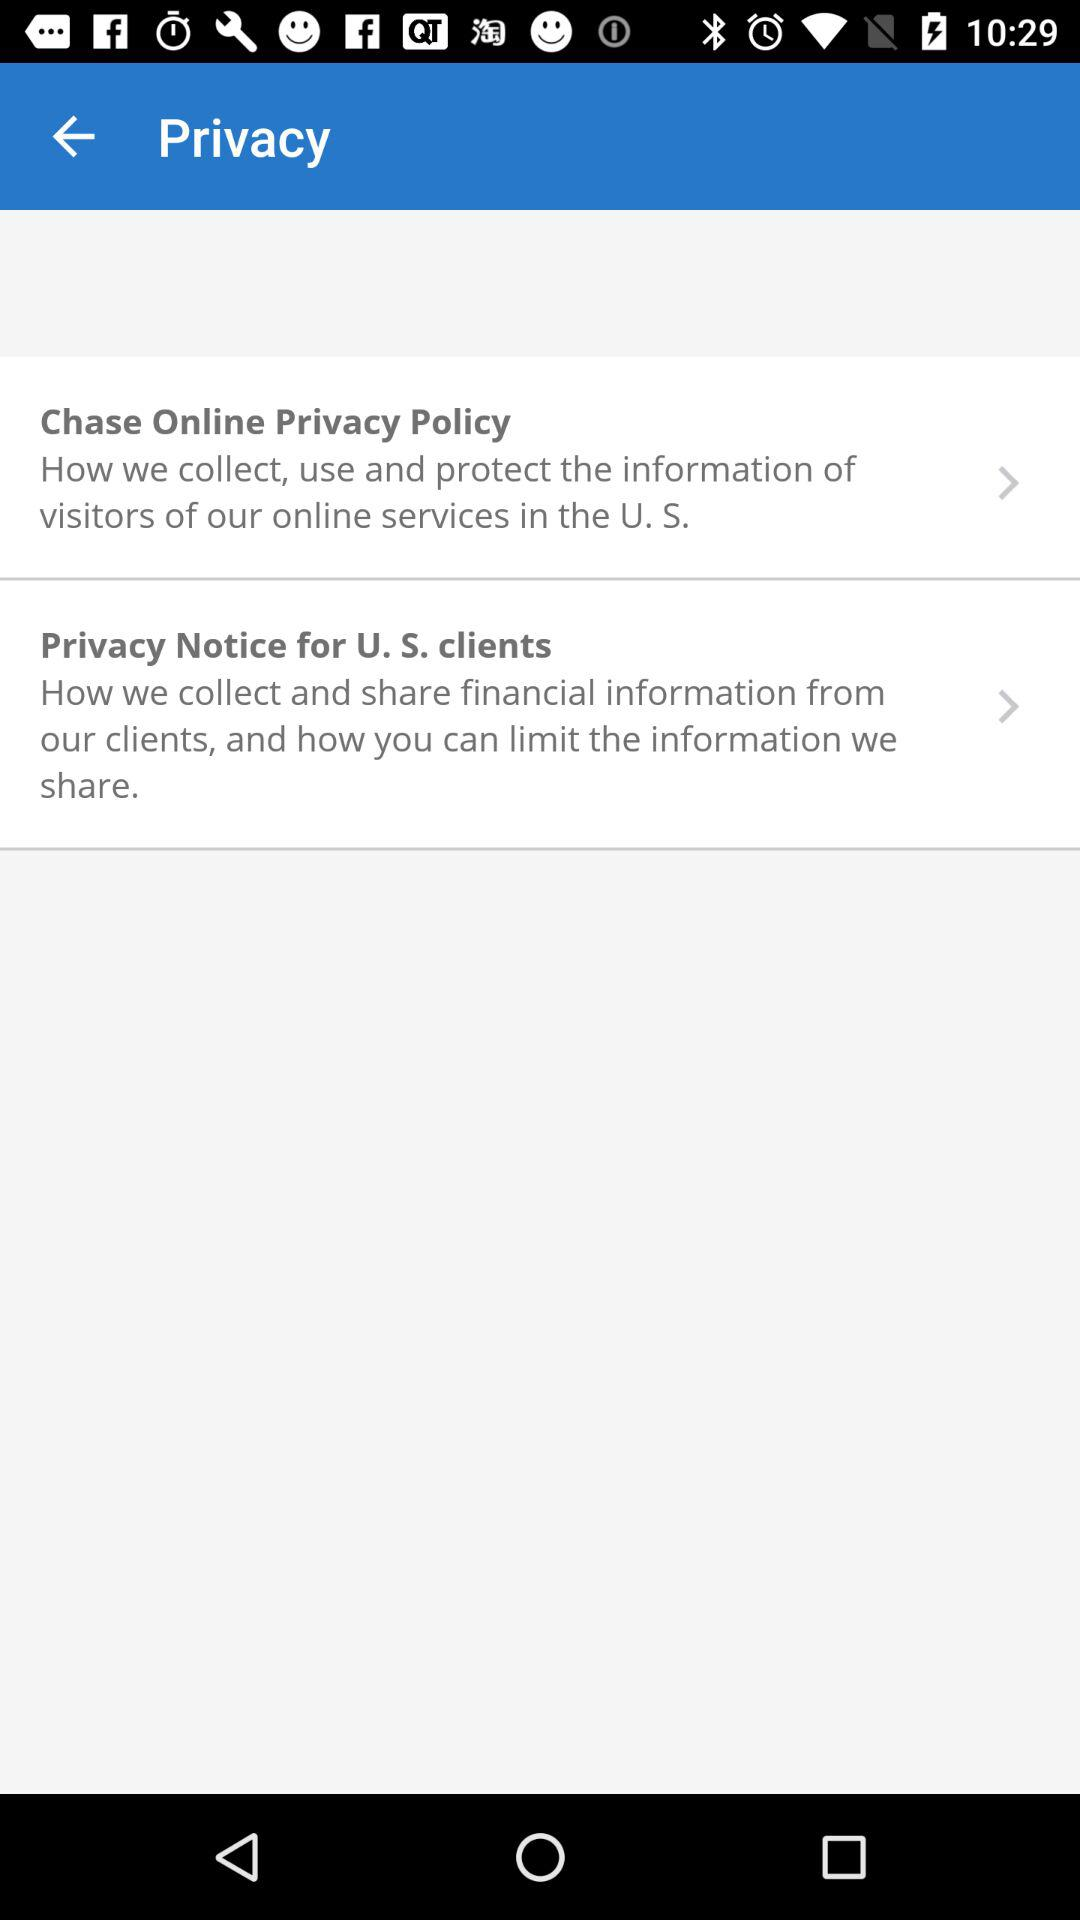How many privacy policy links are there?
Answer the question using a single word or phrase. 2 